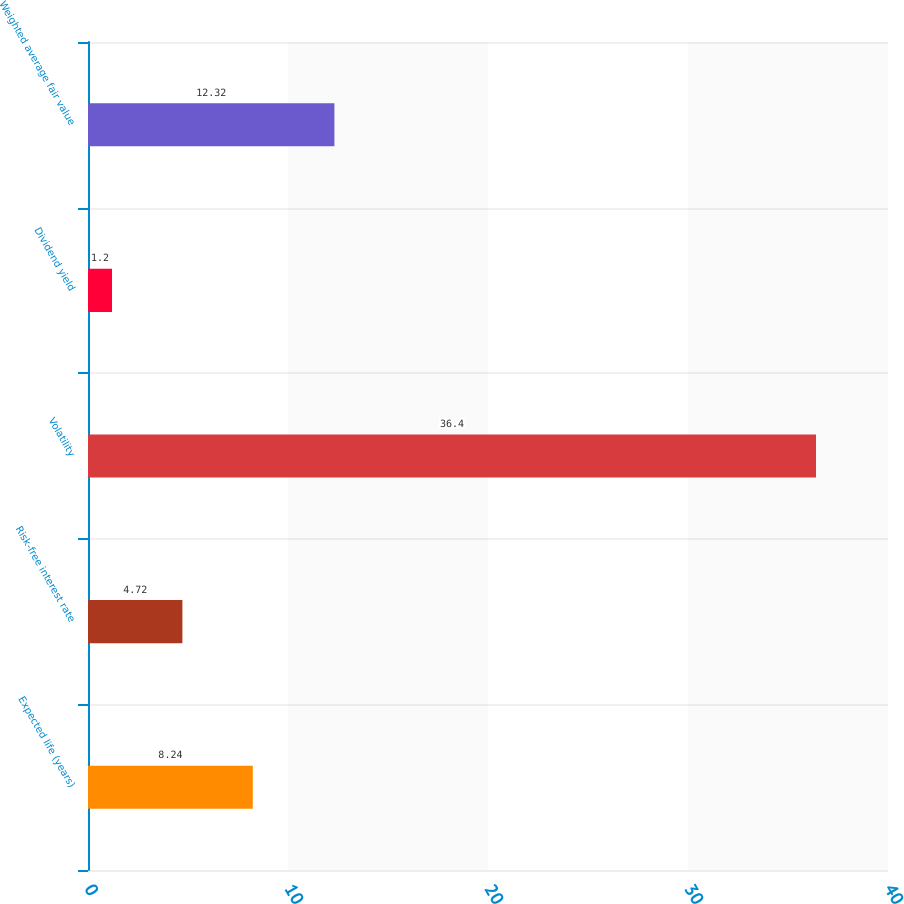Convert chart to OTSL. <chart><loc_0><loc_0><loc_500><loc_500><bar_chart><fcel>Expected life (years)<fcel>Risk-free interest rate<fcel>Volatility<fcel>Dividend yield<fcel>Weighted average fair value<nl><fcel>8.24<fcel>4.72<fcel>36.4<fcel>1.2<fcel>12.32<nl></chart> 